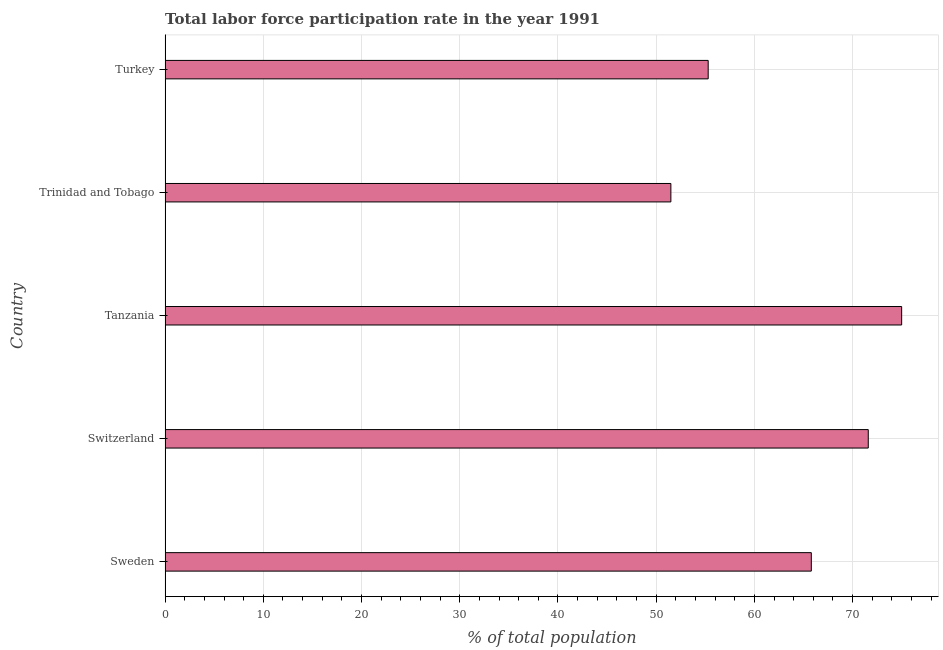Does the graph contain grids?
Offer a very short reply. Yes. What is the title of the graph?
Your response must be concise. Total labor force participation rate in the year 1991. What is the label or title of the X-axis?
Provide a short and direct response. % of total population. What is the label or title of the Y-axis?
Ensure brevity in your answer.  Country. What is the total labor force participation rate in Tanzania?
Keep it short and to the point. 75. Across all countries, what is the maximum total labor force participation rate?
Provide a short and direct response. 75. Across all countries, what is the minimum total labor force participation rate?
Offer a terse response. 51.5. In which country was the total labor force participation rate maximum?
Offer a terse response. Tanzania. In which country was the total labor force participation rate minimum?
Provide a short and direct response. Trinidad and Tobago. What is the sum of the total labor force participation rate?
Give a very brief answer. 319.2. What is the average total labor force participation rate per country?
Your response must be concise. 63.84. What is the median total labor force participation rate?
Your answer should be very brief. 65.8. What is the ratio of the total labor force participation rate in Tanzania to that in Turkey?
Ensure brevity in your answer.  1.36. Is the total labor force participation rate in Switzerland less than that in Trinidad and Tobago?
Provide a succinct answer. No. What is the difference between the highest and the second highest total labor force participation rate?
Provide a short and direct response. 3.4. What is the difference between the highest and the lowest total labor force participation rate?
Offer a terse response. 23.5. What is the % of total population in Sweden?
Ensure brevity in your answer.  65.8. What is the % of total population in Switzerland?
Provide a succinct answer. 71.6. What is the % of total population of Tanzania?
Offer a very short reply. 75. What is the % of total population of Trinidad and Tobago?
Your response must be concise. 51.5. What is the % of total population of Turkey?
Give a very brief answer. 55.3. What is the difference between the % of total population in Sweden and Switzerland?
Your answer should be compact. -5.8. What is the difference between the % of total population in Switzerland and Trinidad and Tobago?
Offer a terse response. 20.1. What is the difference between the % of total population in Tanzania and Trinidad and Tobago?
Your response must be concise. 23.5. What is the ratio of the % of total population in Sweden to that in Switzerland?
Your answer should be very brief. 0.92. What is the ratio of the % of total population in Sweden to that in Tanzania?
Make the answer very short. 0.88. What is the ratio of the % of total population in Sweden to that in Trinidad and Tobago?
Make the answer very short. 1.28. What is the ratio of the % of total population in Sweden to that in Turkey?
Provide a succinct answer. 1.19. What is the ratio of the % of total population in Switzerland to that in Tanzania?
Your answer should be very brief. 0.95. What is the ratio of the % of total population in Switzerland to that in Trinidad and Tobago?
Your response must be concise. 1.39. What is the ratio of the % of total population in Switzerland to that in Turkey?
Your answer should be compact. 1.29. What is the ratio of the % of total population in Tanzania to that in Trinidad and Tobago?
Offer a very short reply. 1.46. What is the ratio of the % of total population in Tanzania to that in Turkey?
Your answer should be compact. 1.36. 